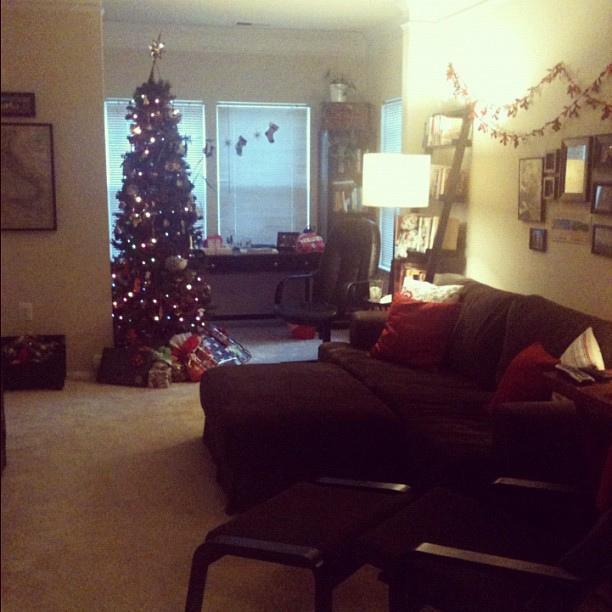How many windows are there?
Give a very brief answer. 3. How many laps do you see?
Give a very brief answer. 0. How many chairs are there?
Give a very brief answer. 2. 